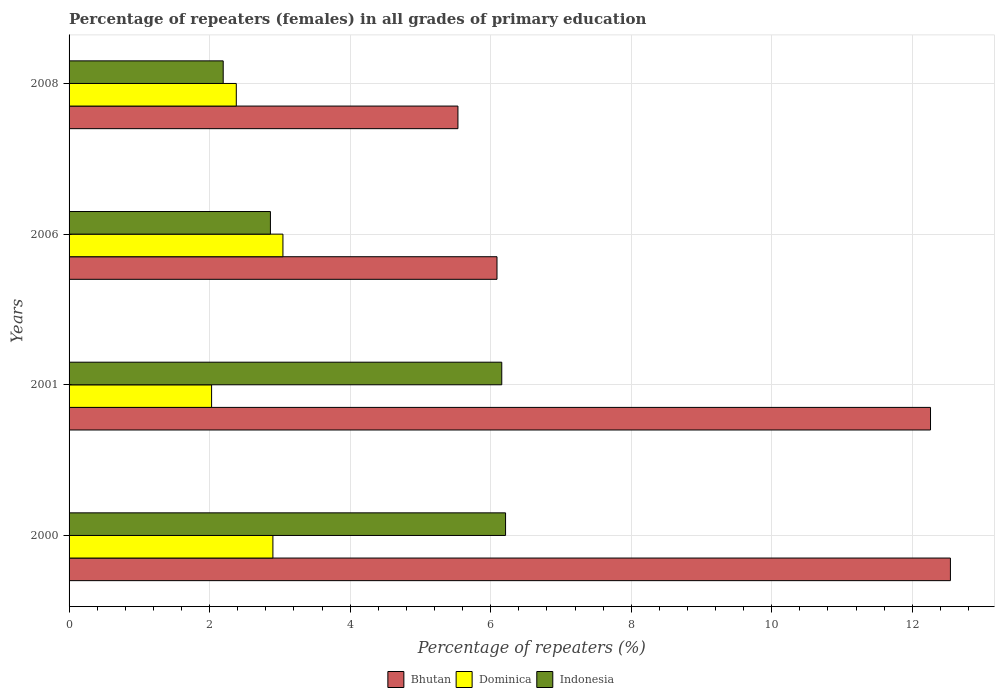How many different coloured bars are there?
Offer a terse response. 3. How many groups of bars are there?
Provide a short and direct response. 4. How many bars are there on the 1st tick from the bottom?
Ensure brevity in your answer.  3. What is the label of the 3rd group of bars from the top?
Offer a very short reply. 2001. In how many cases, is the number of bars for a given year not equal to the number of legend labels?
Offer a terse response. 0. What is the percentage of repeaters (females) in Indonesia in 2000?
Keep it short and to the point. 6.21. Across all years, what is the maximum percentage of repeaters (females) in Bhutan?
Offer a terse response. 12.54. Across all years, what is the minimum percentage of repeaters (females) in Bhutan?
Provide a short and direct response. 5.53. In which year was the percentage of repeaters (females) in Dominica maximum?
Offer a terse response. 2006. In which year was the percentage of repeaters (females) in Bhutan minimum?
Give a very brief answer. 2008. What is the total percentage of repeaters (females) in Dominica in the graph?
Your answer should be compact. 10.35. What is the difference between the percentage of repeaters (females) in Dominica in 2006 and that in 2008?
Provide a succinct answer. 0.66. What is the difference between the percentage of repeaters (females) in Bhutan in 2000 and the percentage of repeaters (females) in Dominica in 2008?
Your response must be concise. 10.16. What is the average percentage of repeaters (females) in Dominica per year?
Offer a terse response. 2.59. In the year 2006, what is the difference between the percentage of repeaters (females) in Indonesia and percentage of repeaters (females) in Dominica?
Provide a succinct answer. -0.18. What is the ratio of the percentage of repeaters (females) in Bhutan in 2000 to that in 2006?
Your answer should be compact. 2.06. Is the percentage of repeaters (females) in Indonesia in 2000 less than that in 2001?
Make the answer very short. No. Is the difference between the percentage of repeaters (females) in Indonesia in 2006 and 2008 greater than the difference between the percentage of repeaters (females) in Dominica in 2006 and 2008?
Provide a short and direct response. Yes. What is the difference between the highest and the second highest percentage of repeaters (females) in Bhutan?
Your answer should be very brief. 0.28. What is the difference between the highest and the lowest percentage of repeaters (females) in Indonesia?
Your response must be concise. 4.02. Is the sum of the percentage of repeaters (females) in Dominica in 2001 and 2006 greater than the maximum percentage of repeaters (females) in Bhutan across all years?
Provide a succinct answer. No. What does the 2nd bar from the top in 2006 represents?
Offer a terse response. Dominica. What does the 3rd bar from the bottom in 2006 represents?
Offer a very short reply. Indonesia. How many bars are there?
Provide a short and direct response. 12. Are all the bars in the graph horizontal?
Keep it short and to the point. Yes. How many years are there in the graph?
Provide a short and direct response. 4. Does the graph contain grids?
Offer a very short reply. Yes. How many legend labels are there?
Keep it short and to the point. 3. How are the legend labels stacked?
Keep it short and to the point. Horizontal. What is the title of the graph?
Your response must be concise. Percentage of repeaters (females) in all grades of primary education. Does "Angola" appear as one of the legend labels in the graph?
Provide a short and direct response. No. What is the label or title of the X-axis?
Your response must be concise. Percentage of repeaters (%). What is the Percentage of repeaters (%) of Bhutan in 2000?
Provide a succinct answer. 12.54. What is the Percentage of repeaters (%) in Dominica in 2000?
Give a very brief answer. 2.9. What is the Percentage of repeaters (%) in Indonesia in 2000?
Make the answer very short. 6.21. What is the Percentage of repeaters (%) in Bhutan in 2001?
Your answer should be compact. 12.26. What is the Percentage of repeaters (%) of Dominica in 2001?
Your response must be concise. 2.03. What is the Percentage of repeaters (%) in Indonesia in 2001?
Your answer should be compact. 6.16. What is the Percentage of repeaters (%) in Bhutan in 2006?
Give a very brief answer. 6.09. What is the Percentage of repeaters (%) in Dominica in 2006?
Your answer should be compact. 3.04. What is the Percentage of repeaters (%) in Indonesia in 2006?
Give a very brief answer. 2.87. What is the Percentage of repeaters (%) of Bhutan in 2008?
Provide a short and direct response. 5.53. What is the Percentage of repeaters (%) of Dominica in 2008?
Your response must be concise. 2.38. What is the Percentage of repeaters (%) in Indonesia in 2008?
Keep it short and to the point. 2.19. Across all years, what is the maximum Percentage of repeaters (%) in Bhutan?
Your answer should be very brief. 12.54. Across all years, what is the maximum Percentage of repeaters (%) of Dominica?
Keep it short and to the point. 3.04. Across all years, what is the maximum Percentage of repeaters (%) of Indonesia?
Your response must be concise. 6.21. Across all years, what is the minimum Percentage of repeaters (%) of Bhutan?
Give a very brief answer. 5.53. Across all years, what is the minimum Percentage of repeaters (%) in Dominica?
Your answer should be compact. 2.03. Across all years, what is the minimum Percentage of repeaters (%) of Indonesia?
Offer a terse response. 2.19. What is the total Percentage of repeaters (%) in Bhutan in the graph?
Make the answer very short. 36.43. What is the total Percentage of repeaters (%) of Dominica in the graph?
Provide a short and direct response. 10.35. What is the total Percentage of repeaters (%) in Indonesia in the graph?
Offer a very short reply. 17.43. What is the difference between the Percentage of repeaters (%) in Bhutan in 2000 and that in 2001?
Provide a short and direct response. 0.28. What is the difference between the Percentage of repeaters (%) of Dominica in 2000 and that in 2001?
Your response must be concise. 0.87. What is the difference between the Percentage of repeaters (%) in Indonesia in 2000 and that in 2001?
Provide a succinct answer. 0.05. What is the difference between the Percentage of repeaters (%) in Bhutan in 2000 and that in 2006?
Your answer should be compact. 6.45. What is the difference between the Percentage of repeaters (%) in Dominica in 2000 and that in 2006?
Provide a short and direct response. -0.14. What is the difference between the Percentage of repeaters (%) of Indonesia in 2000 and that in 2006?
Keep it short and to the point. 3.35. What is the difference between the Percentage of repeaters (%) of Bhutan in 2000 and that in 2008?
Provide a succinct answer. 7.01. What is the difference between the Percentage of repeaters (%) of Dominica in 2000 and that in 2008?
Keep it short and to the point. 0.52. What is the difference between the Percentage of repeaters (%) in Indonesia in 2000 and that in 2008?
Your answer should be very brief. 4.02. What is the difference between the Percentage of repeaters (%) in Bhutan in 2001 and that in 2006?
Offer a terse response. 6.17. What is the difference between the Percentage of repeaters (%) in Dominica in 2001 and that in 2006?
Provide a short and direct response. -1.02. What is the difference between the Percentage of repeaters (%) in Indonesia in 2001 and that in 2006?
Ensure brevity in your answer.  3.29. What is the difference between the Percentage of repeaters (%) of Bhutan in 2001 and that in 2008?
Provide a short and direct response. 6.73. What is the difference between the Percentage of repeaters (%) of Dominica in 2001 and that in 2008?
Ensure brevity in your answer.  -0.35. What is the difference between the Percentage of repeaters (%) of Indonesia in 2001 and that in 2008?
Your response must be concise. 3.96. What is the difference between the Percentage of repeaters (%) in Bhutan in 2006 and that in 2008?
Provide a short and direct response. 0.56. What is the difference between the Percentage of repeaters (%) in Dominica in 2006 and that in 2008?
Give a very brief answer. 0.66. What is the difference between the Percentage of repeaters (%) in Indonesia in 2006 and that in 2008?
Provide a succinct answer. 0.67. What is the difference between the Percentage of repeaters (%) in Bhutan in 2000 and the Percentage of repeaters (%) in Dominica in 2001?
Your answer should be compact. 10.51. What is the difference between the Percentage of repeaters (%) of Bhutan in 2000 and the Percentage of repeaters (%) of Indonesia in 2001?
Your answer should be very brief. 6.38. What is the difference between the Percentage of repeaters (%) in Dominica in 2000 and the Percentage of repeaters (%) in Indonesia in 2001?
Your answer should be very brief. -3.26. What is the difference between the Percentage of repeaters (%) of Bhutan in 2000 and the Percentage of repeaters (%) of Dominica in 2006?
Offer a very short reply. 9.5. What is the difference between the Percentage of repeaters (%) in Bhutan in 2000 and the Percentage of repeaters (%) in Indonesia in 2006?
Ensure brevity in your answer.  9.68. What is the difference between the Percentage of repeaters (%) in Dominica in 2000 and the Percentage of repeaters (%) in Indonesia in 2006?
Make the answer very short. 0.04. What is the difference between the Percentage of repeaters (%) of Bhutan in 2000 and the Percentage of repeaters (%) of Dominica in 2008?
Offer a very short reply. 10.16. What is the difference between the Percentage of repeaters (%) of Bhutan in 2000 and the Percentage of repeaters (%) of Indonesia in 2008?
Offer a very short reply. 10.35. What is the difference between the Percentage of repeaters (%) of Dominica in 2000 and the Percentage of repeaters (%) of Indonesia in 2008?
Ensure brevity in your answer.  0.71. What is the difference between the Percentage of repeaters (%) in Bhutan in 2001 and the Percentage of repeaters (%) in Dominica in 2006?
Offer a very short reply. 9.22. What is the difference between the Percentage of repeaters (%) in Bhutan in 2001 and the Percentage of repeaters (%) in Indonesia in 2006?
Provide a succinct answer. 9.39. What is the difference between the Percentage of repeaters (%) of Dominica in 2001 and the Percentage of repeaters (%) of Indonesia in 2006?
Keep it short and to the point. -0.84. What is the difference between the Percentage of repeaters (%) of Bhutan in 2001 and the Percentage of repeaters (%) of Dominica in 2008?
Keep it short and to the point. 9.88. What is the difference between the Percentage of repeaters (%) in Bhutan in 2001 and the Percentage of repeaters (%) in Indonesia in 2008?
Your answer should be compact. 10.07. What is the difference between the Percentage of repeaters (%) in Dominica in 2001 and the Percentage of repeaters (%) in Indonesia in 2008?
Your response must be concise. -0.17. What is the difference between the Percentage of repeaters (%) in Bhutan in 2006 and the Percentage of repeaters (%) in Dominica in 2008?
Make the answer very short. 3.71. What is the difference between the Percentage of repeaters (%) in Bhutan in 2006 and the Percentage of repeaters (%) in Indonesia in 2008?
Offer a terse response. 3.9. What is the difference between the Percentage of repeaters (%) in Dominica in 2006 and the Percentage of repeaters (%) in Indonesia in 2008?
Provide a succinct answer. 0.85. What is the average Percentage of repeaters (%) of Bhutan per year?
Provide a succinct answer. 9.11. What is the average Percentage of repeaters (%) in Dominica per year?
Offer a terse response. 2.59. What is the average Percentage of repeaters (%) in Indonesia per year?
Give a very brief answer. 4.36. In the year 2000, what is the difference between the Percentage of repeaters (%) of Bhutan and Percentage of repeaters (%) of Dominica?
Provide a succinct answer. 9.64. In the year 2000, what is the difference between the Percentage of repeaters (%) of Bhutan and Percentage of repeaters (%) of Indonesia?
Offer a terse response. 6.33. In the year 2000, what is the difference between the Percentage of repeaters (%) of Dominica and Percentage of repeaters (%) of Indonesia?
Offer a terse response. -3.31. In the year 2001, what is the difference between the Percentage of repeaters (%) in Bhutan and Percentage of repeaters (%) in Dominica?
Ensure brevity in your answer.  10.23. In the year 2001, what is the difference between the Percentage of repeaters (%) of Bhutan and Percentage of repeaters (%) of Indonesia?
Offer a very short reply. 6.1. In the year 2001, what is the difference between the Percentage of repeaters (%) in Dominica and Percentage of repeaters (%) in Indonesia?
Your response must be concise. -4.13. In the year 2006, what is the difference between the Percentage of repeaters (%) of Bhutan and Percentage of repeaters (%) of Dominica?
Make the answer very short. 3.05. In the year 2006, what is the difference between the Percentage of repeaters (%) of Bhutan and Percentage of repeaters (%) of Indonesia?
Provide a succinct answer. 3.22. In the year 2006, what is the difference between the Percentage of repeaters (%) of Dominica and Percentage of repeaters (%) of Indonesia?
Give a very brief answer. 0.18. In the year 2008, what is the difference between the Percentage of repeaters (%) of Bhutan and Percentage of repeaters (%) of Dominica?
Provide a succinct answer. 3.15. In the year 2008, what is the difference between the Percentage of repeaters (%) in Bhutan and Percentage of repeaters (%) in Indonesia?
Provide a succinct answer. 3.34. In the year 2008, what is the difference between the Percentage of repeaters (%) in Dominica and Percentage of repeaters (%) in Indonesia?
Provide a short and direct response. 0.19. What is the ratio of the Percentage of repeaters (%) of Bhutan in 2000 to that in 2001?
Give a very brief answer. 1.02. What is the ratio of the Percentage of repeaters (%) of Dominica in 2000 to that in 2001?
Your answer should be very brief. 1.43. What is the ratio of the Percentage of repeaters (%) of Indonesia in 2000 to that in 2001?
Provide a short and direct response. 1.01. What is the ratio of the Percentage of repeaters (%) in Bhutan in 2000 to that in 2006?
Give a very brief answer. 2.06. What is the ratio of the Percentage of repeaters (%) of Dominica in 2000 to that in 2006?
Your answer should be very brief. 0.95. What is the ratio of the Percentage of repeaters (%) of Indonesia in 2000 to that in 2006?
Keep it short and to the point. 2.17. What is the ratio of the Percentage of repeaters (%) in Bhutan in 2000 to that in 2008?
Your answer should be compact. 2.27. What is the ratio of the Percentage of repeaters (%) in Dominica in 2000 to that in 2008?
Provide a succinct answer. 1.22. What is the ratio of the Percentage of repeaters (%) in Indonesia in 2000 to that in 2008?
Provide a short and direct response. 2.83. What is the ratio of the Percentage of repeaters (%) of Bhutan in 2001 to that in 2006?
Offer a very short reply. 2.01. What is the ratio of the Percentage of repeaters (%) of Dominica in 2001 to that in 2006?
Offer a terse response. 0.67. What is the ratio of the Percentage of repeaters (%) of Indonesia in 2001 to that in 2006?
Offer a very short reply. 2.15. What is the ratio of the Percentage of repeaters (%) of Bhutan in 2001 to that in 2008?
Offer a terse response. 2.22. What is the ratio of the Percentage of repeaters (%) of Dominica in 2001 to that in 2008?
Give a very brief answer. 0.85. What is the ratio of the Percentage of repeaters (%) in Indonesia in 2001 to that in 2008?
Your answer should be compact. 2.81. What is the ratio of the Percentage of repeaters (%) of Bhutan in 2006 to that in 2008?
Your answer should be very brief. 1.1. What is the ratio of the Percentage of repeaters (%) in Dominica in 2006 to that in 2008?
Your answer should be very brief. 1.28. What is the ratio of the Percentage of repeaters (%) in Indonesia in 2006 to that in 2008?
Offer a terse response. 1.31. What is the difference between the highest and the second highest Percentage of repeaters (%) of Bhutan?
Keep it short and to the point. 0.28. What is the difference between the highest and the second highest Percentage of repeaters (%) of Dominica?
Your response must be concise. 0.14. What is the difference between the highest and the second highest Percentage of repeaters (%) in Indonesia?
Make the answer very short. 0.05. What is the difference between the highest and the lowest Percentage of repeaters (%) in Bhutan?
Your answer should be very brief. 7.01. What is the difference between the highest and the lowest Percentage of repeaters (%) in Dominica?
Offer a terse response. 1.02. What is the difference between the highest and the lowest Percentage of repeaters (%) of Indonesia?
Your answer should be very brief. 4.02. 